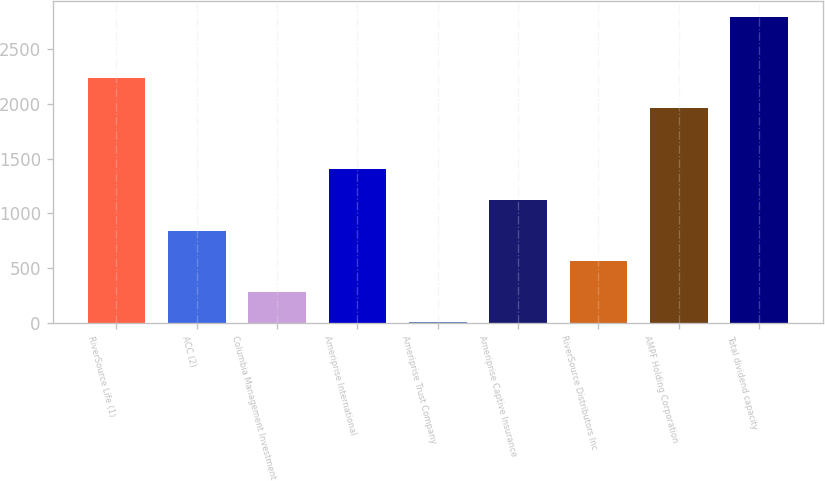Convert chart. <chart><loc_0><loc_0><loc_500><loc_500><bar_chart><fcel>RiverSource Life (1)<fcel>ACC (2)<fcel>Columbia Management Investment<fcel>Ameriprise International<fcel>Ameriprise Trust Company<fcel>Ameriprise Captive Insurance<fcel>RiverSource Distributors Inc<fcel>AMPF Holding Corporation<fcel>Total dividend capacity<nl><fcel>2236.4<fcel>842.4<fcel>284.8<fcel>1400<fcel>6<fcel>1121.2<fcel>563.6<fcel>1957.6<fcel>2794<nl></chart> 